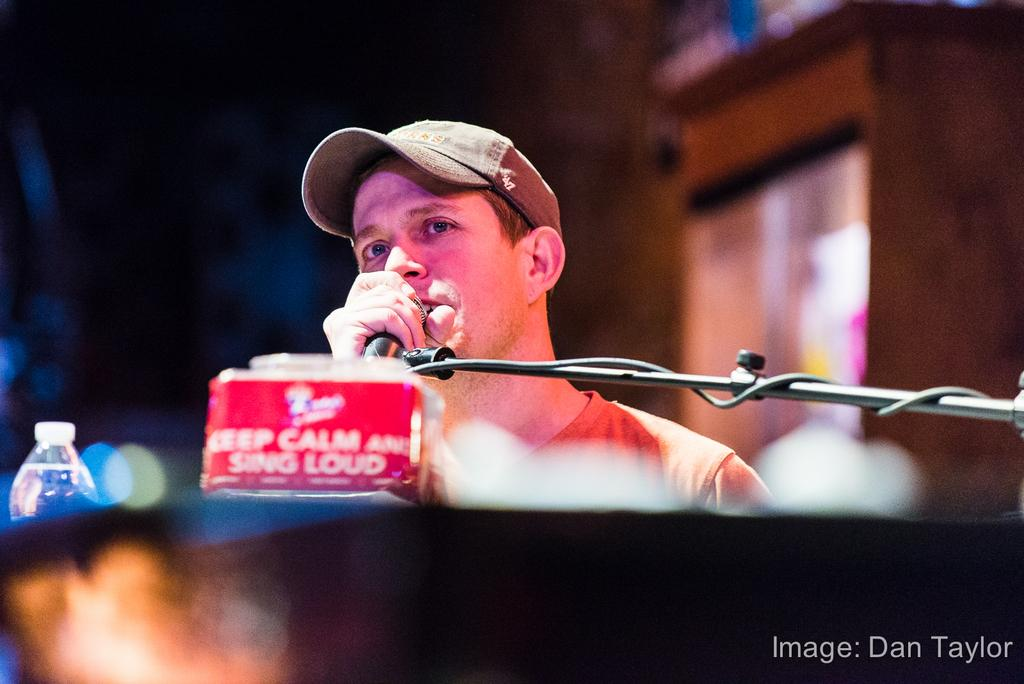Who is the main subject in the image? There is a man in the image. What is the man wearing on his head? The man is wearing a hat. What object is the man holding in the image? The man is holding a microphone. What is the man's position in the office in the image? There is no office present in the image, and the man's position is not mentioned. 